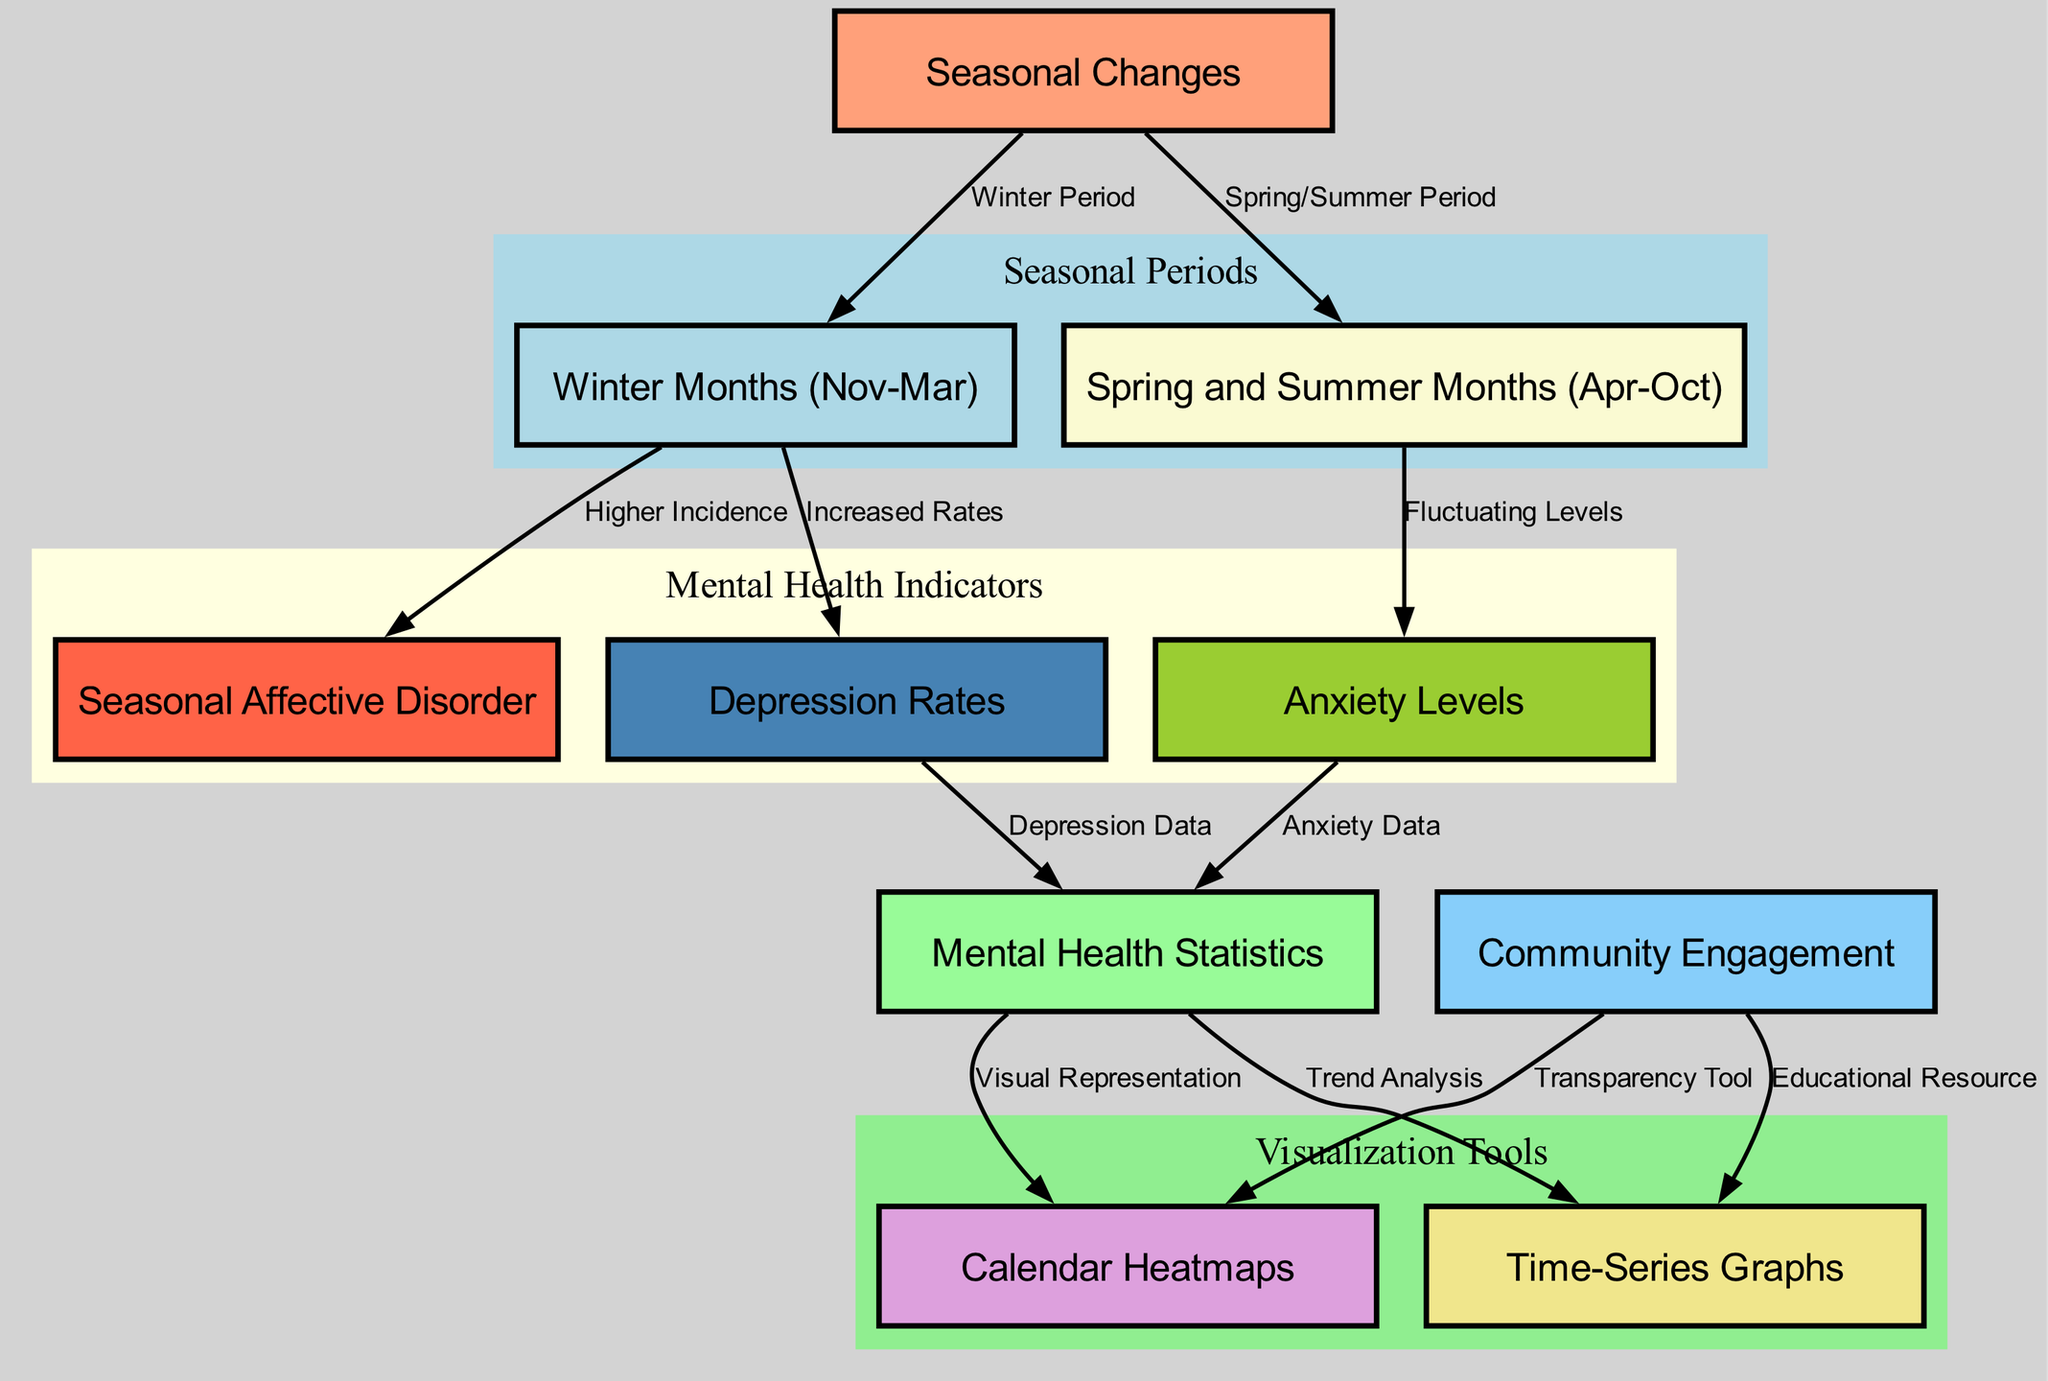What is the main focus of the diagram? The diagram focuses on the relationship between seasonal changes and mental health statistics within the community, highlighting how different seasons impact mental health metrics.
Answer: Seasonal changes and mental health statistics How many nodes are present in the diagram? By counting all the nodes listed, there are a total of 10 distinct nodes that represent various aspects related to the topic.
Answer: 10 Which seasonal period shows a higher incidence of Seasonal Affective Disorder? The winter months (from November to March) are indicated as having a higher incidence of Seasonal Affective Disorder compared to other periods.
Answer: Winter Months (Nov-Mar) What visual representation tools are identified in the diagram for mental health statistics? The diagram specifies two tools for visual representation: calendar heatmaps and time-series graphs that help depict trends and data effectively.
Answer: Calendar Heatmaps and Time-Series Graphs What effect does Spring and Summer have on Anxiety Levels? During the Spring and Summer months (from April to October), anxiety levels are indicated to fluctuate rather than show a consistent increase or decrease.
Answer: Fluctuating Levels What is indicated about the depression rates during the winter months? The diagram notes that there are increased rates of depression during the winter months, connecting seasonal changes to mental health issues.
Answer: Increased Rates What role does community engagement have concerning the visualization tools? Community engagement serves as a transparency tool and educational resource, highlighting its importance in understanding and addressing mental health statistics.
Answer: Transparency Tool and Educational Resource Which node represents metrics specifically related to mental health? The node labeled "Mental Health Statistics" is the one that encompasses all related metrics such as depression rates and anxiety levels.
Answer: Mental Health Statistics How many relationships (edges) exist between nodes in the diagram? By counting the connections or relationships, the diagram displays a total of 11 edges showing various interactions and dependencies among the nodes.
Answer: 11 